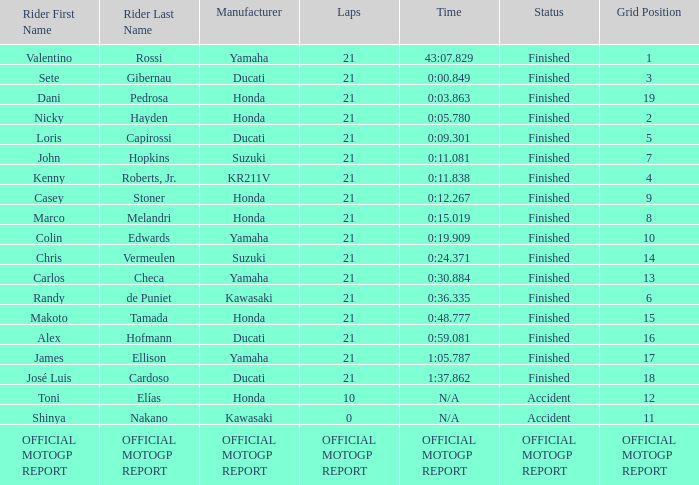What is the time/retired for the rider with the manufacturuer yamaha, grod of 1 and 21 total laps? 43:07.829. 